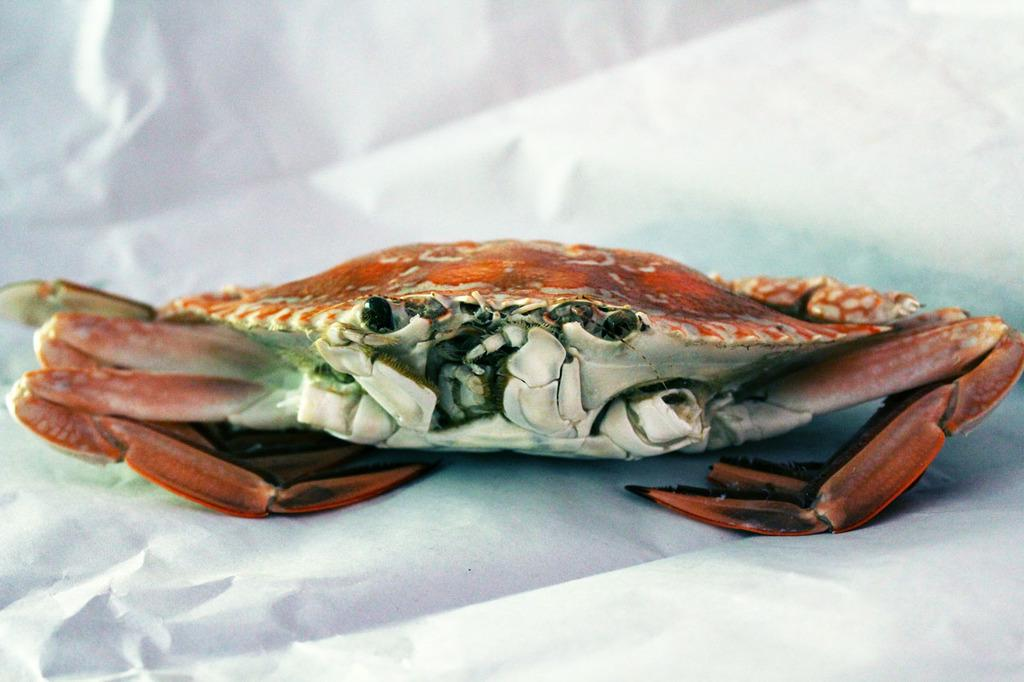What is the main subject of the image? The main subject of the image is a crab. Where is the crab located in the image? The crab is on a white paper. What type of camera is being used to take a picture of the meeting in the image? There is no meeting or camera present in the image; it only features a crab on a white paper. Is the crab holding a stick in the image? There is no stick present in the image; it only features a crab on a white paper. 